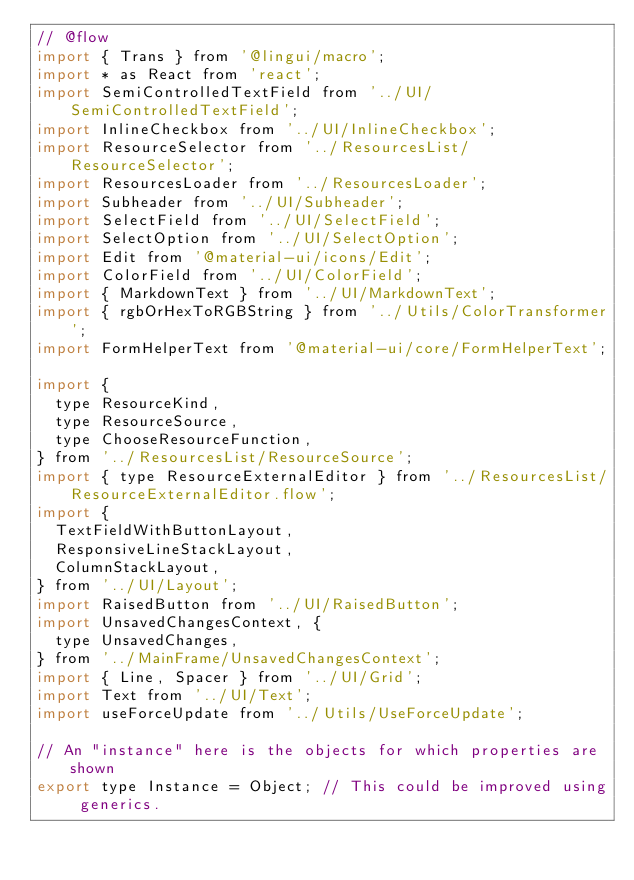Convert code to text. <code><loc_0><loc_0><loc_500><loc_500><_JavaScript_>// @flow
import { Trans } from '@lingui/macro';
import * as React from 'react';
import SemiControlledTextField from '../UI/SemiControlledTextField';
import InlineCheckbox from '../UI/InlineCheckbox';
import ResourceSelector from '../ResourcesList/ResourceSelector';
import ResourcesLoader from '../ResourcesLoader';
import Subheader from '../UI/Subheader';
import SelectField from '../UI/SelectField';
import SelectOption from '../UI/SelectOption';
import Edit from '@material-ui/icons/Edit';
import ColorField from '../UI/ColorField';
import { MarkdownText } from '../UI/MarkdownText';
import { rgbOrHexToRGBString } from '../Utils/ColorTransformer';
import FormHelperText from '@material-ui/core/FormHelperText';

import {
  type ResourceKind,
  type ResourceSource,
  type ChooseResourceFunction,
} from '../ResourcesList/ResourceSource';
import { type ResourceExternalEditor } from '../ResourcesList/ResourceExternalEditor.flow';
import {
  TextFieldWithButtonLayout,
  ResponsiveLineStackLayout,
  ColumnStackLayout,
} from '../UI/Layout';
import RaisedButton from '../UI/RaisedButton';
import UnsavedChangesContext, {
  type UnsavedChanges,
} from '../MainFrame/UnsavedChangesContext';
import { Line, Spacer } from '../UI/Grid';
import Text from '../UI/Text';
import useForceUpdate from '../Utils/UseForceUpdate';

// An "instance" here is the objects for which properties are shown
export type Instance = Object; // This could be improved using generics.</code> 